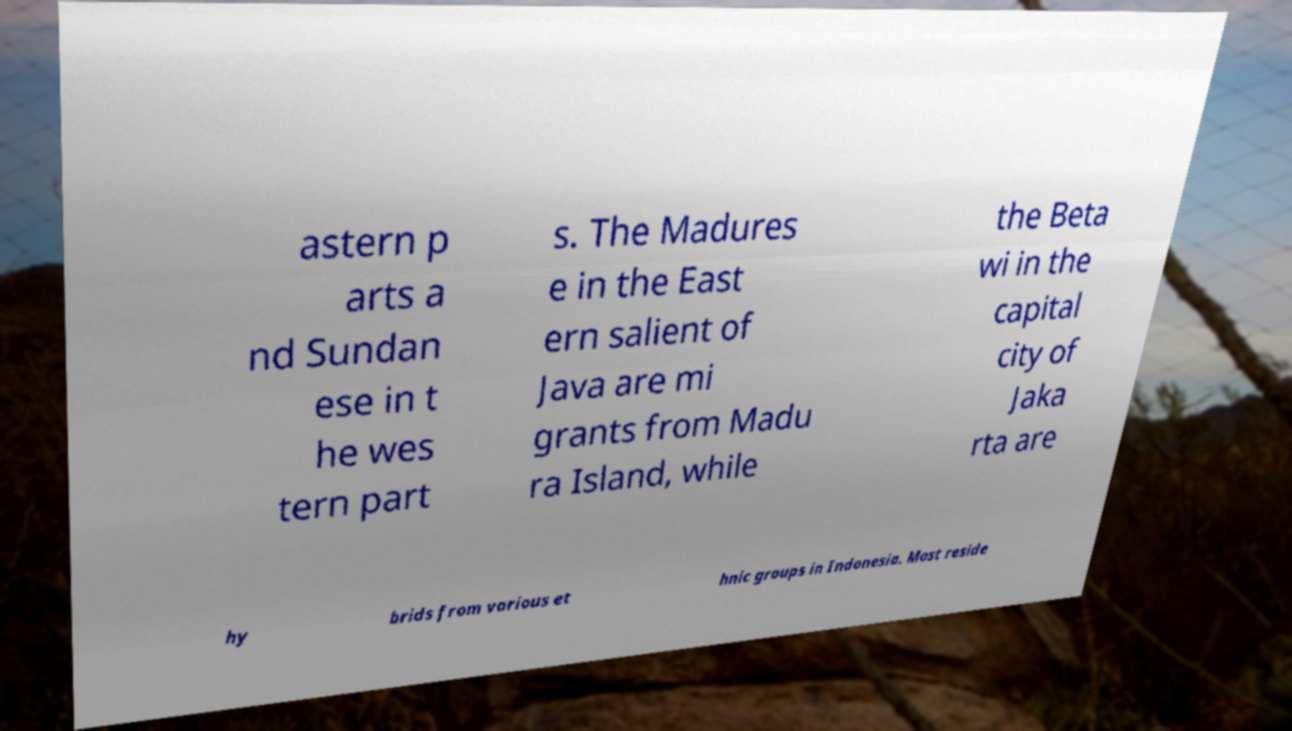Please identify and transcribe the text found in this image. astern p arts a nd Sundan ese in t he wes tern part s. The Madures e in the East ern salient of Java are mi grants from Madu ra Island, while the Beta wi in the capital city of Jaka rta are hy brids from various et hnic groups in Indonesia. Most reside 